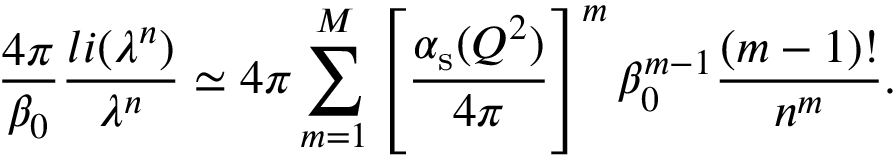<formula> <loc_0><loc_0><loc_500><loc_500>\frac { 4 \pi } { \beta _ { 0 } } \frac { l i ( \lambda ^ { n } ) } { \lambda ^ { n } } \simeq 4 \pi \sum _ { m = 1 } ^ { M } \left [ \frac { \alpha _ { s } ( Q ^ { 2 } ) } { 4 \pi } \right ] ^ { m } \beta _ { 0 } ^ { m - 1 } \frac { ( m - 1 ) ! } { n ^ { m } } .</formula> 